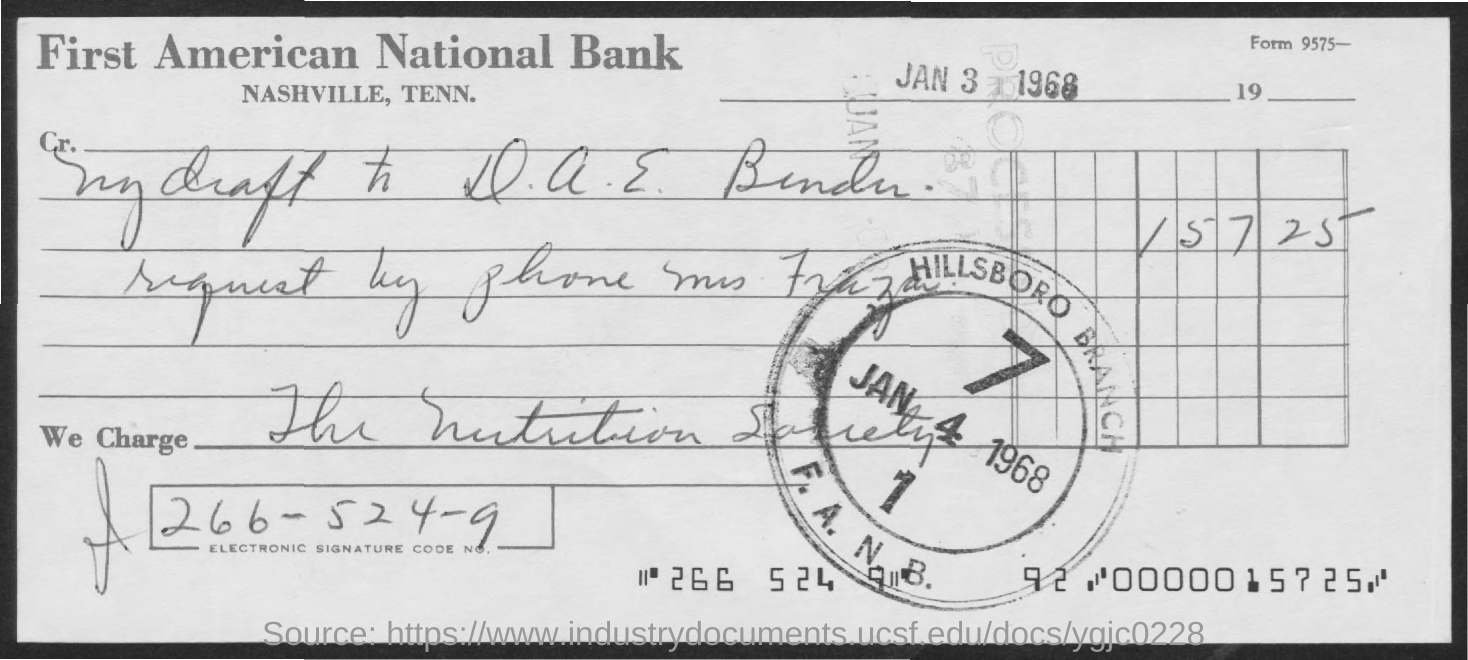What is the date on the document?
Provide a succinct answer. Jan 3 1968. What is the electronic signature code no?
Offer a very short reply. 266-524-9. 